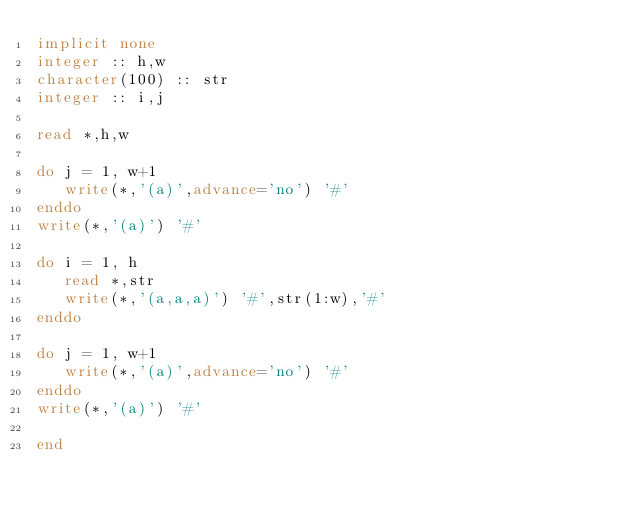Convert code to text. <code><loc_0><loc_0><loc_500><loc_500><_FORTRAN_>implicit none
integer :: h,w
character(100) :: str
integer :: i,j

read *,h,w

do j = 1, w+1
   write(*,'(a)',advance='no') '#'
enddo
write(*,'(a)') '#'

do i = 1, h
   read *,str
   write(*,'(a,a,a)') '#',str(1:w),'#'
enddo

do j = 1, w+1
   write(*,'(a)',advance='no') '#'
enddo
write(*,'(a)') '#'

end</code> 